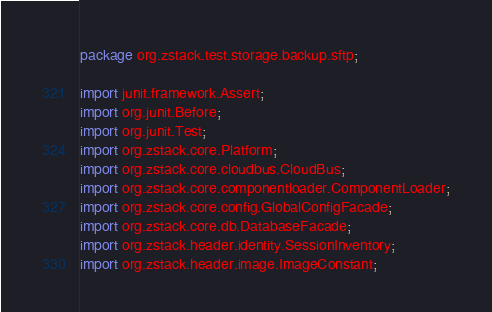Convert code to text. <code><loc_0><loc_0><loc_500><loc_500><_Java_>package org.zstack.test.storage.backup.sftp;

import junit.framework.Assert;
import org.junit.Before;
import org.junit.Test;
import org.zstack.core.Platform;
import org.zstack.core.cloudbus.CloudBus;
import org.zstack.core.componentloader.ComponentLoader;
import org.zstack.core.config.GlobalConfigFacade;
import org.zstack.core.db.DatabaseFacade;
import org.zstack.header.identity.SessionInventory;
import org.zstack.header.image.ImageConstant;</code> 